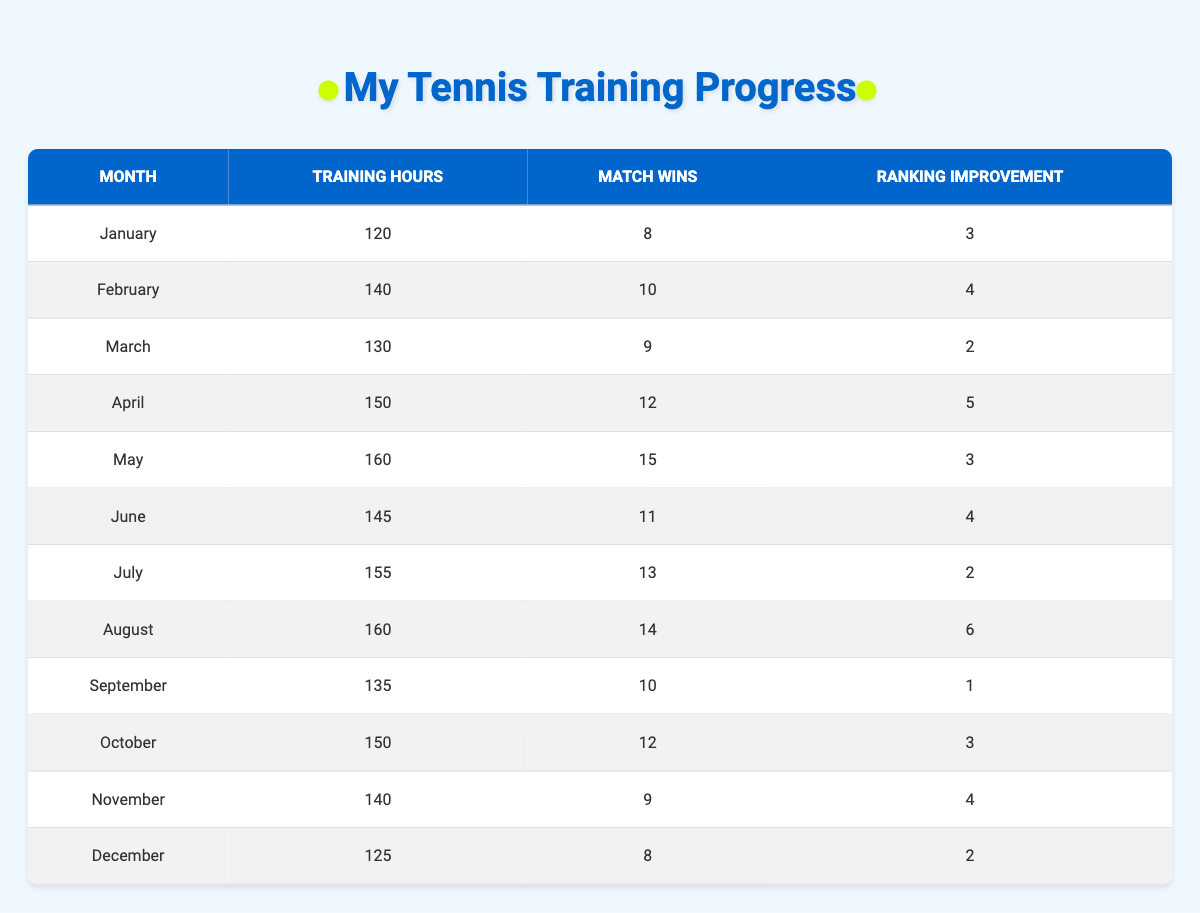What month had the highest number of Training Hours? Looking through the table, August has the highest value for Training Hours at 160.
Answer: August What is the total number of Match Wins recorded from January to June? To find the total, we sum the Match Wins from January (8), February (10), March (9), April (12), May (15), and June (11). That gives us 8 + 10 + 9 + 12 + 15 + 11 = 65.
Answer: 65 Did the player show a Ranking Improvement every month? Observing the data, the Ranking Improvement is 0 in September and July; therefore, the improvement was not consistent every month.
Answer: No What is the average Ranking Improvement from August to December? We first add the Ranking Improvements from August (6), September (1), October (3), November (4), and December (2). This gives us 6 + 1 + 3 + 4 + 2 = 16. There are 5 months in this range, so we divide 16 by 5 to get 16/5 = 3.2.
Answer: 3.2 Which month had the highest Match Wins with fewer than 150 Training Hours? By looking at the table, both May and June, which had 160 and 145 Training Hours, respectively, June had the most wins (11) but because of the constraint, we look at March, which had 9 Match Wins with 130 Training Hours.
Answer: March What is the difference in Ranking Improvement between April and September? First, we find the Ranking Improvement for April, which is 5, and September, which is 1. The difference is calculated as 5 - 1 = 4.
Answer: 4 In which month did the player have more Match Wins than the average for the year? The total Match Wins for the year is 131 (sum of all Match Wins), and dividing by 12 months gives an average of approximately 10.92. The months with Match Wins exceeding that average are February (10), April (12), May (15), June (11), July (13), and August (14).
Answer: February, April, May, June, July, August Was there any month where the Training Hours were below 130 while also having fewer than 9 Match Wins? The only month that fits this criteria is December, which has 125 Training Hours and 8 Match Wins.
Answer: Yes 